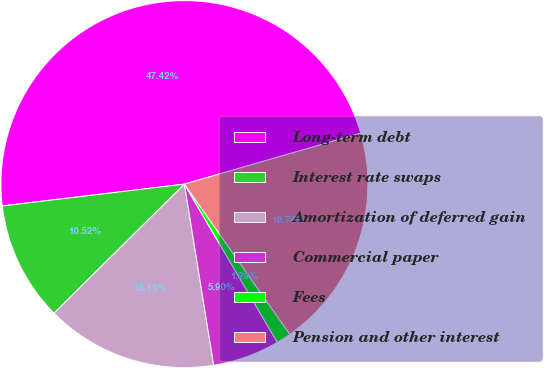Convert chart. <chart><loc_0><loc_0><loc_500><loc_500><pie_chart><fcel>Long-term debt<fcel>Interest rate swaps<fcel>Amortization of deferred gain<fcel>Commercial paper<fcel>Fees<fcel>Pension and other interest<nl><fcel>47.42%<fcel>10.52%<fcel>15.13%<fcel>5.9%<fcel>1.29%<fcel>19.74%<nl></chart> 